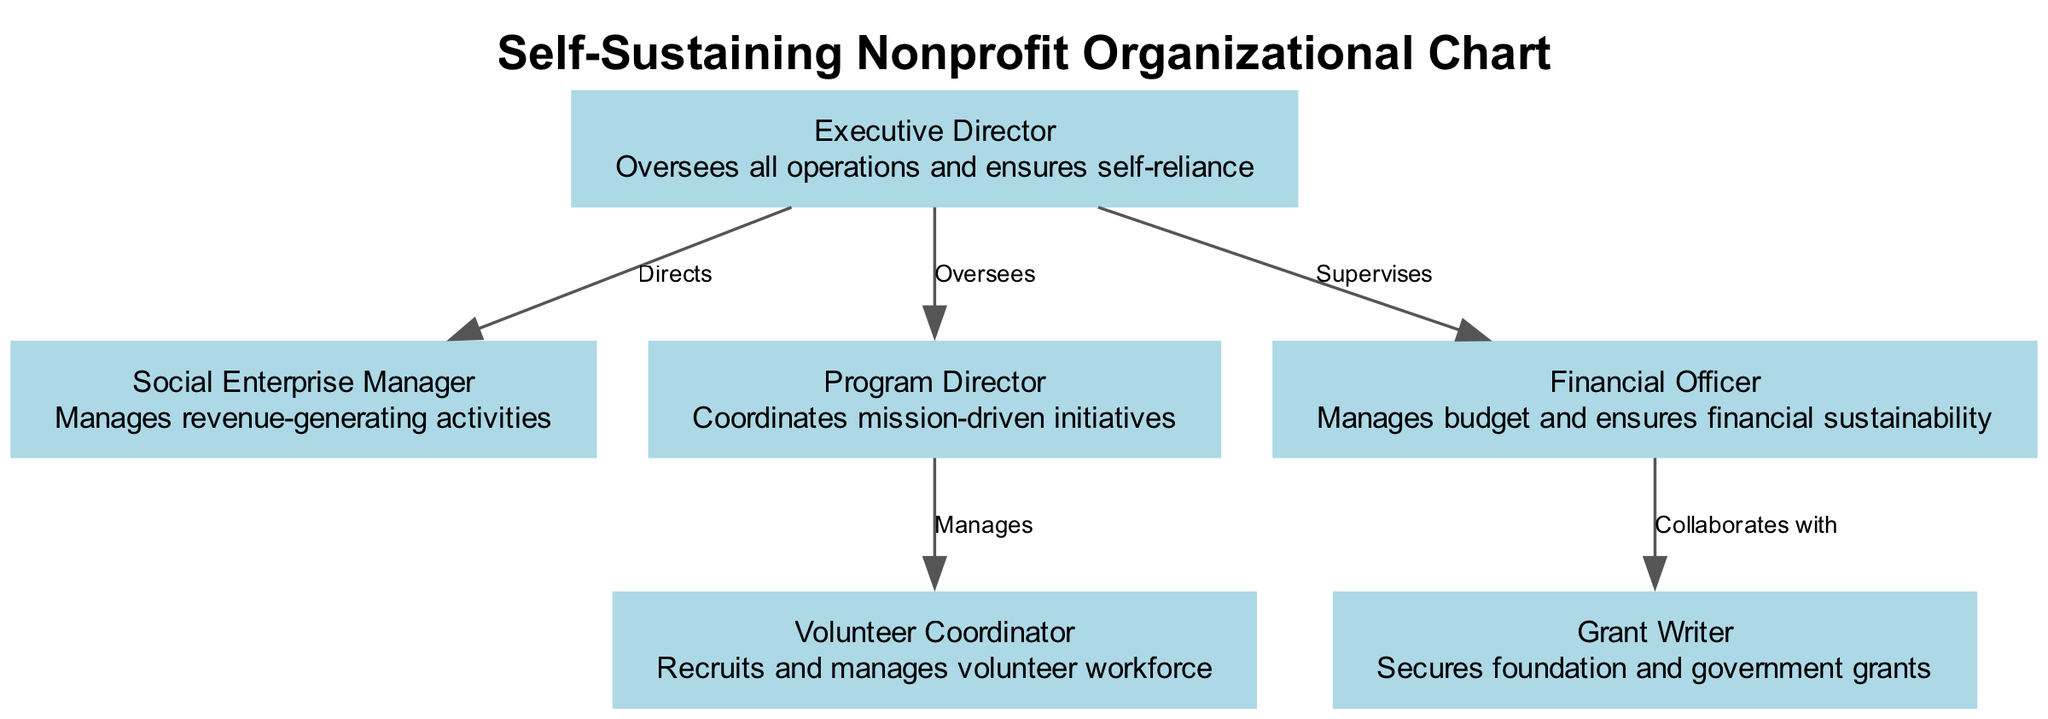What is the role of the Executive Director? The Executive Director oversees all operations and ensures self-reliance, which is stated in the description on the node representing this position.
Answer: Oversees all operations and ensures self-reliance How many nodes are there in the diagram? By counting each individual role represented in the diagram, there are a total of 6 nodes.
Answer: 6 What does the Program Director manage? The Program Director manages the volunteer workforce, as indicated by the edge connecting this role to the Volunteer Coordinator with a "Manages" label.
Answer: Volunteer workforce Who does the Financial Officer collaborate with? The Financial Officer collaborates with the Grant Writer, as evidenced by the edge labeled "Collaborates with" that connects these two nodes.
Answer: Grant Writer How many roles directly report to the Executive Director? The Executive Director has 3 roles that report directly to them: the Social Enterprise Manager, Program Director, and Financial Officer.
Answer: 3 What is the purpose of the Social Enterprise Manager? The Social Enterprise Manager manages the revenue-generating activities for the organization, as described in the node details.
Answer: Manages revenue-generating activities Which position manages the budget? The Financial Officer is the position responsible for managing the budget, as stated in its description.
Answer: Financial Officer What is the relationship between the Program Director and the Volunteer Coordinator? The Program Director manages the Volunteer Coordinator, which is clarified by the directed edge labeled "Manages" between these two nodes.
Answer: Manages What is the primary function of the Grant Writer? The primary function of the Grant Writer is to secure foundation and government grants, as explained in their node's description.
Answer: Secures foundation and government grants 